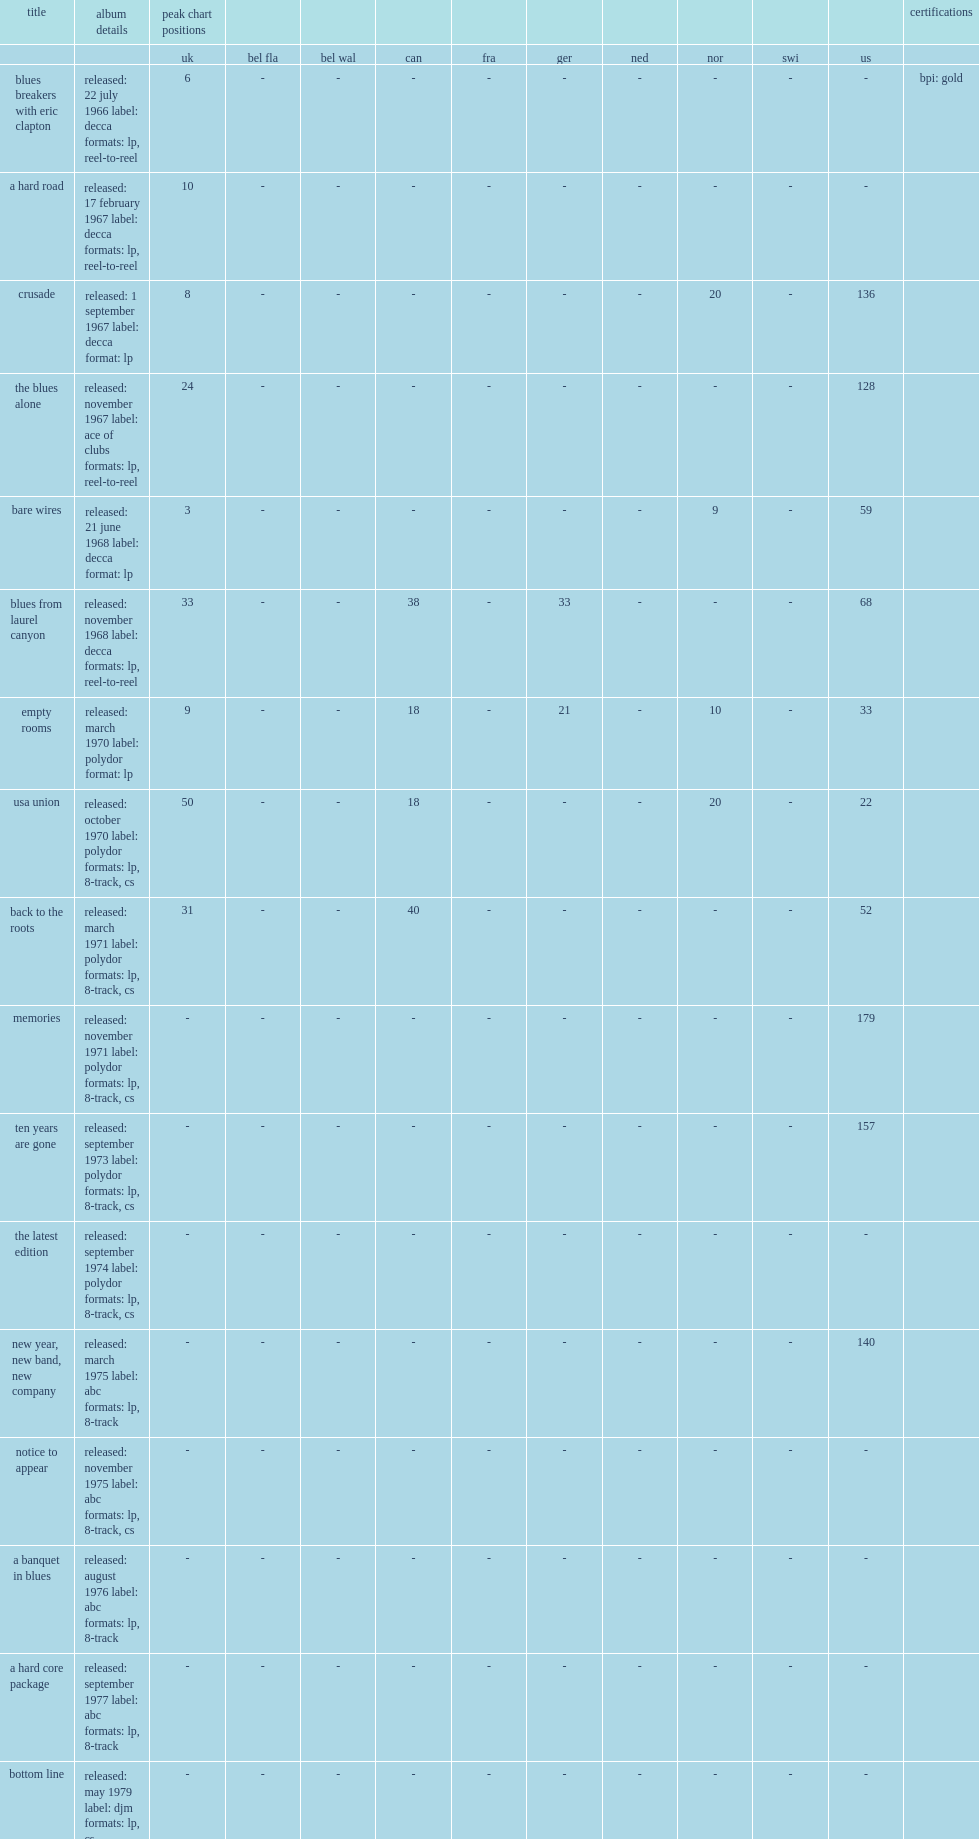Could you help me parse every detail presented in this table? {'header': ['title', 'album details', 'peak chart positions', '', '', '', '', '', '', '', '', '', 'certifications'], 'rows': [['', '', 'uk', 'bel fla', 'bel wal', 'can', 'fra', 'ger', 'ned', 'nor', 'swi', 'us', ''], ['blues breakers with eric clapton', 'released: 22 july 1966 label: decca formats: lp, reel-to-reel', '6', '-', '-', '-', '-', '-', '-', '-', '-', '-', 'bpi: gold'], ['a hard road', 'released: 17 february 1967 label: decca formats: lp, reel-to-reel', '10', '-', '-', '-', '-', '-', '-', '-', '-', '-', ''], ['crusade', 'released: 1 september 1967 label: decca format: lp', '8', '-', '-', '-', '-', '-', '-', '20', '-', '136', ''], ['the blues alone', 'released: november 1967 label: ace of clubs formats: lp, reel-to-reel', '24', '-', '-', '-', '-', '-', '-', '-', '-', '128', ''], ['bare wires', 'released: 21 june 1968 label: decca format: lp', '3', '-', '-', '-', '-', '-', '-', '9', '-', '59', ''], ['blues from laurel canyon', 'released: november 1968 label: decca formats: lp, reel-to-reel', '33', '-', '-', '38', '-', '33', '-', '-', '-', '68', ''], ['empty rooms', 'released: march 1970 label: polydor format: lp', '9', '-', '-', '18', '-', '21', '-', '10', '-', '33', ''], ['usa union', 'released: october 1970 label: polydor formats: lp, 8-track, cs', '50', '-', '-', '18', '-', '-', '-', '20', '-', '22', ''], ['back to the roots', 'released: march 1971 label: polydor formats: lp, 8-track, cs', '31', '-', '-', '40', '-', '-', '-', '-', '-', '52', ''], ['memories', 'released: november 1971 label: polydor formats: lp, 8-track, cs', '-', '-', '-', '-', '-', '-', '-', '-', '-', '179', ''], ['ten years are gone', 'released: september 1973 label: polydor formats: lp, 8-track, cs', '-', '-', '-', '-', '-', '-', '-', '-', '-', '157', ''], ['the latest edition', 'released: september 1974 label: polydor formats: lp, 8-track, cs', '-', '-', '-', '-', '-', '-', '-', '-', '-', '-', ''], ['new year, new band, new company', 'released: march 1975 label: abc formats: lp, 8-track', '-', '-', '-', '-', '-', '-', '-', '-', '-', '140', ''], ['notice to appear', 'released: november 1975 label: abc formats: lp, 8-track, cs', '-', '-', '-', '-', '-', '-', '-', '-', '-', '-', ''], ['a banquet in blues', 'released: august 1976 label: abc formats: lp, 8-track', '-', '-', '-', '-', '-', '-', '-', '-', '-', '-', ''], ['a hard core package', 'released: september 1977 label: abc formats: lp, 8-track', '-', '-', '-', '-', '-', '-', '-', '-', '-', '-', ''], ['bottom line', 'released: may 1979 label: djm formats: lp, cs', '-', '-', '-', '-', '-', '-', '-', '-', '-', '-', ''], ['no more interviews', 'released: january 1980 label: djm formats: lp, 8-track, cs', '-', '-', '-', '-', '-', '-', '-', '-', '-', '-', ''], ['road show blues', 'released: may 1981 label: djm format: lp', '-', '-', '-', '-', '-', '-', '-', '-', '-', '-', ''], ['return of the bluesbreakers', 'released: 1985 label: aim formats: cd, lp', '-', '-', '-', '-', '-', '-', '-', '-', '-', '-', ''], ['chicago line', 'released: october 1988 label: island formats: cd, lp, cs', '-', '-', '-', '-', '-', '-', '-', '-', '-', '-', ''], ['a sense of place', 'released: march 1990 label: island formats: cd, lp, cs', '-', '-', '-', '-', '-', '-', '54', '-', '-', '170', ''], ['cross country blues', 'released: 1992 label: one way format: cd', '-', '-', '-', '-', '-', '-', '54', '-', '-', '170', ''], ['wake up call', 'released: 6 april 1993 label: silvertone formats: cd, lp, cs', '61', '-', '-', '-', '-', '-', '73', '-', '-', '-', ''], ['spinning coin', 'released: 28 february 1995 label: silvertone formats: cd, lp, cs', '-', '-', '-', '-', '-', '-', '-', '-', '-', '-', ''], ['blues for the lost days', 'released: 15 april 1997 label: silvertone format: cd', '185', '-', '-', '-', '-', '-', '-', '-', '-', '-', ''], ['padlock on the blues', 'released: 19 april 1999 label: eagle format: cd', '-', '-', '-', '-', '-', '-', '-', '-', '-', '-', ''], ['along for the ride', 'released: 8 may 2001 label: eagle format: cd', '143', '-', '-', '-', '-', '88', '-', '-', '90', '-', ''], ['stories', 'released: 27 august 2002 label: eagle format: cd', '-', '-', '-', '-', '-', '-', '-', '-', '-', '-', ''], ['road dogs', 'released: 6 june 2005 label: eagle format: cd', '-', '-', '-', '-', '187', '-', '-', '-', '-', '-', ''], ['in the palace of the king', 'released: 5 march 2007 label: eagle format: cd', '-', '-', '-', '-', '168', '-', '-', '-', '-', '-', ''], ['tough', 'released: 15 september 2009 label: eagle formats: cd, lp, dl', '-', '-', '-', '-', '140', '-', '-', '-', '-', '-', ''], ['a special life', 'released: 13 may 2014 label: forty below formats: cd, lp, dl', '-', '185', '-', '-', '-', '-', '-', '-', '-', '-', ''], ['find a way to care', 'released: 4 september 2015 label: forty below formats: cd, lp, dl', '-', '82', '125', '-', '-', '-', '41', '-', '86', '-', ''], ['talk about that', 'released: 27 january 2017 label: forty below formats: cd, lp, dl', '-', '74', '166', '-', '-', '-', '-', '-', '84', '-', ''], ['nobody told me', 'released: 22 february 2019 label: forty below formats: cd, lp, dl', '-', '69', '76', '-', '195', '28', '88', '-', '16', '-', ''], ['"-" denotes a release that did not chart or was not issued in that region', '', '', '', '', '', '', '', '', '', '', '', '']]} Crusade was john mayall's and bluesbreaker's first release to chart in the us, what the number did he reach on the billboard 200? 136.0. 